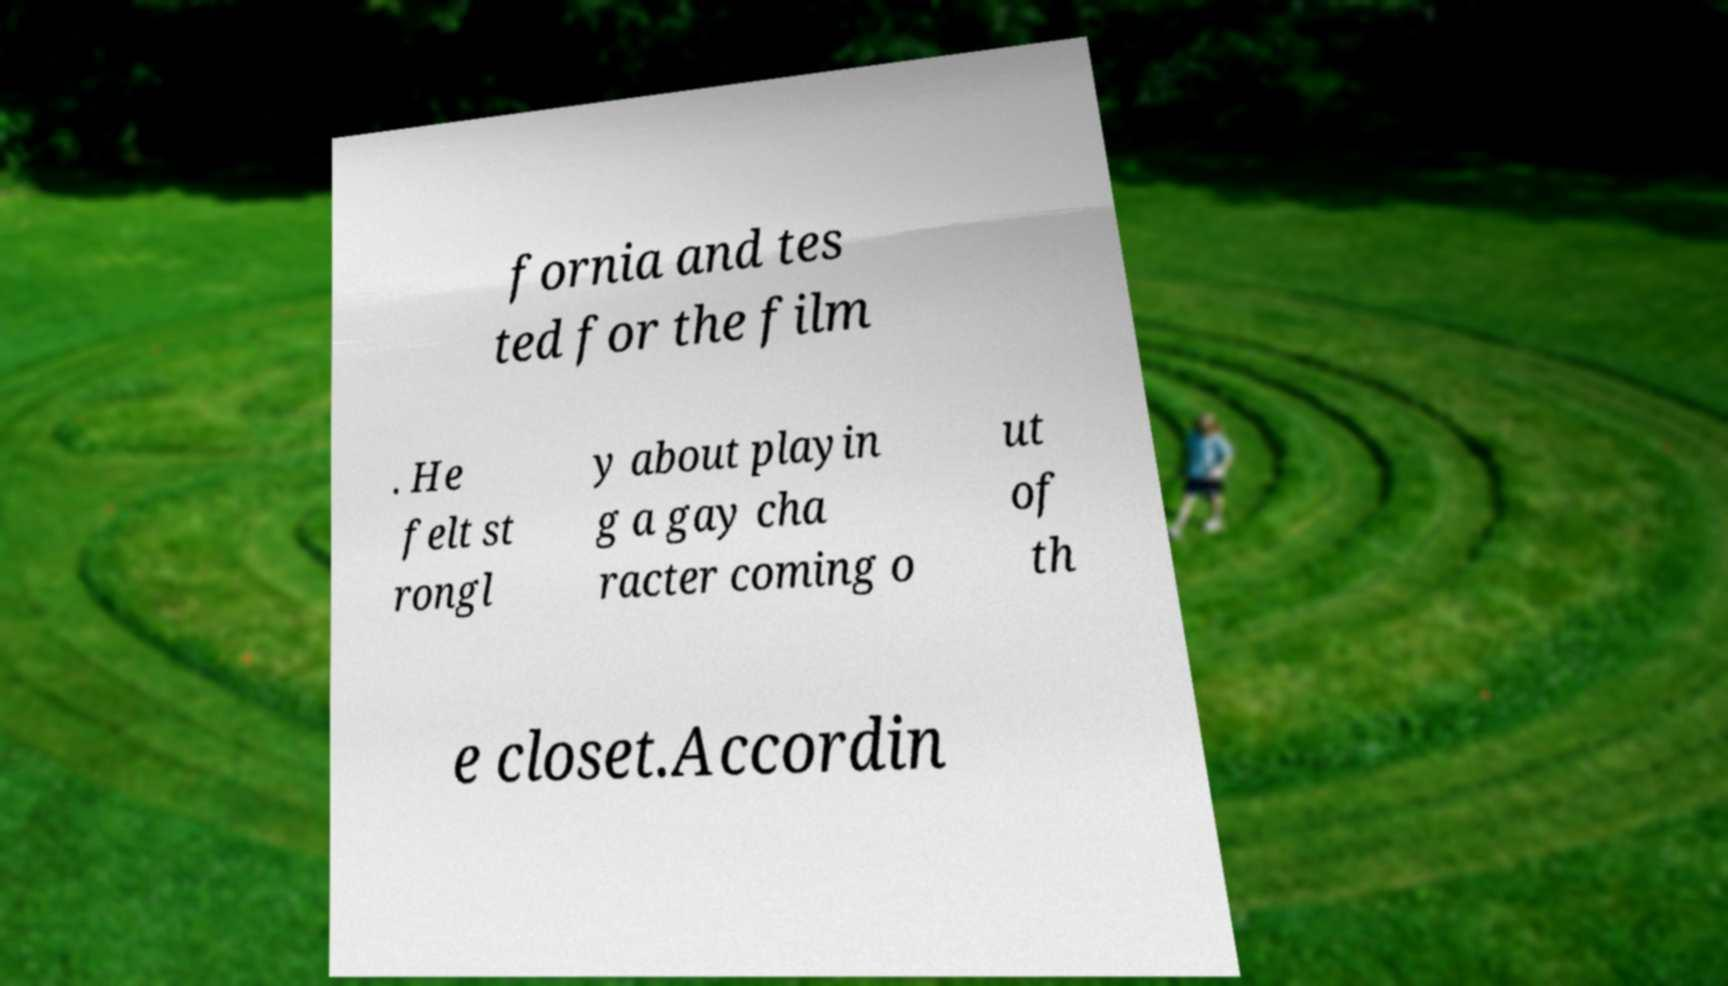Can you accurately transcribe the text from the provided image for me? fornia and tes ted for the film . He felt st rongl y about playin g a gay cha racter coming o ut of th e closet.Accordin 